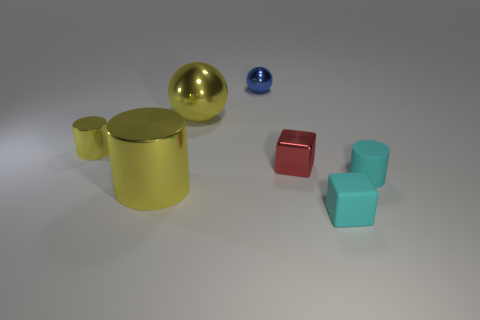Add 2 red cylinders. How many objects exist? 9 Subtract all cylinders. How many objects are left? 4 Add 6 big metallic cylinders. How many big metallic cylinders are left? 7 Add 6 cyan spheres. How many cyan spheres exist? 6 Subtract 0 purple cylinders. How many objects are left? 7 Subtract all yellow metallic cylinders. Subtract all small yellow spheres. How many objects are left? 5 